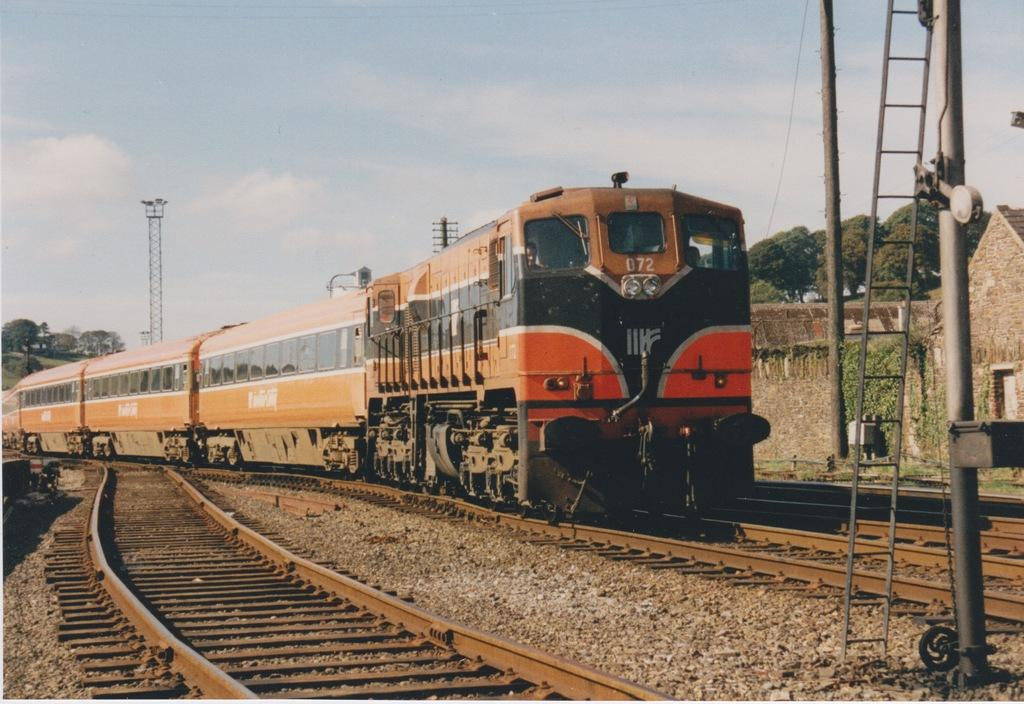What is the main subject of the image? The main subject of the image is a train on the track. What can be seen on either side of the train? There are other tracks on either side of the train. What is the pole in the image used for? The purpose of the pole in the image is not specified, but it could be related to the train or the tracks. What is the wall in the image used for? The wall in the image could be a barrier or part of a structure related to the train or tracks. What type of vegetation is visible in the image? There are trees in the right corner of the image. What advice does the father give to the child in the image? There is no father or child present in the image; it features a train on the track with other tracks, a pole, a wall, and trees. 